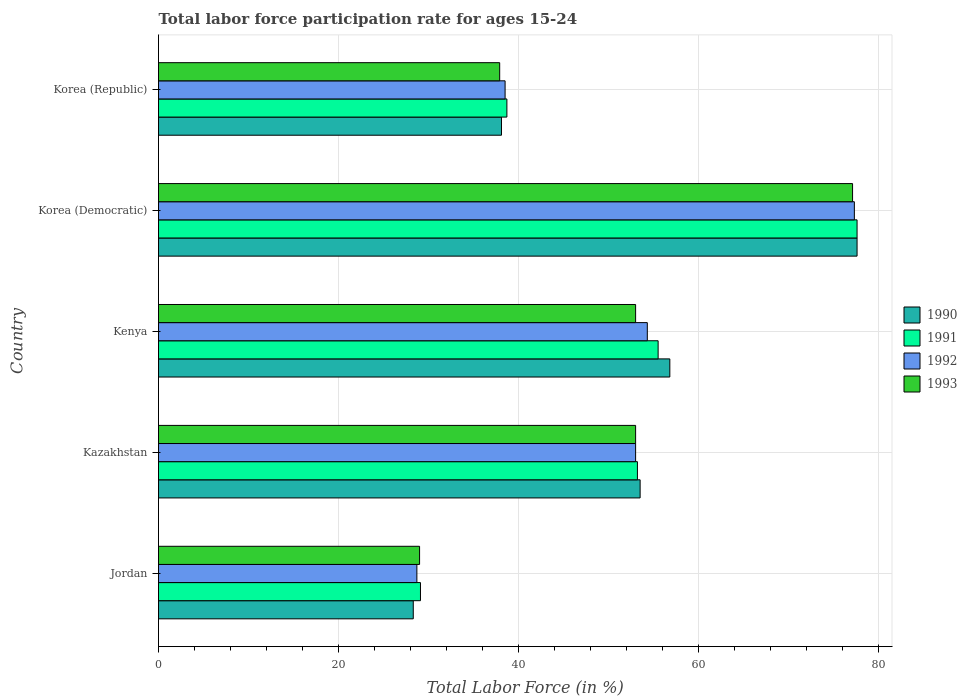How many different coloured bars are there?
Provide a short and direct response. 4. How many groups of bars are there?
Offer a very short reply. 5. Are the number of bars per tick equal to the number of legend labels?
Give a very brief answer. Yes. Are the number of bars on each tick of the Y-axis equal?
Offer a terse response. Yes. How many bars are there on the 2nd tick from the top?
Offer a very short reply. 4. How many bars are there on the 3rd tick from the bottom?
Your response must be concise. 4. What is the label of the 1st group of bars from the top?
Provide a succinct answer. Korea (Republic). In how many cases, is the number of bars for a given country not equal to the number of legend labels?
Your response must be concise. 0. What is the labor force participation rate in 1991 in Korea (Democratic)?
Provide a short and direct response. 77.6. Across all countries, what is the maximum labor force participation rate in 1993?
Provide a short and direct response. 77.1. Across all countries, what is the minimum labor force participation rate in 1990?
Ensure brevity in your answer.  28.3. In which country was the labor force participation rate in 1991 maximum?
Ensure brevity in your answer.  Korea (Democratic). In which country was the labor force participation rate in 1993 minimum?
Offer a terse response. Jordan. What is the total labor force participation rate in 1991 in the graph?
Provide a succinct answer. 254.1. What is the difference between the labor force participation rate in 1990 in Kenya and that in Korea (Democratic)?
Your answer should be very brief. -20.8. What is the difference between the labor force participation rate in 1993 in Jordan and the labor force participation rate in 1991 in Korea (Republic)?
Ensure brevity in your answer.  -9.7. What is the average labor force participation rate in 1993 per country?
Make the answer very short. 50. What is the difference between the labor force participation rate in 1991 and labor force participation rate in 1990 in Korea (Democratic)?
Offer a terse response. 0. In how many countries, is the labor force participation rate in 1991 greater than 76 %?
Offer a terse response. 1. What is the ratio of the labor force participation rate in 1992 in Kazakhstan to that in Kenya?
Make the answer very short. 0.98. Is the difference between the labor force participation rate in 1991 in Korea (Democratic) and Korea (Republic) greater than the difference between the labor force participation rate in 1990 in Korea (Democratic) and Korea (Republic)?
Your answer should be compact. No. What is the difference between the highest and the second highest labor force participation rate in 1990?
Keep it short and to the point. 20.8. What is the difference between the highest and the lowest labor force participation rate in 1993?
Provide a short and direct response. 48.1. Is the sum of the labor force participation rate in 1991 in Jordan and Kenya greater than the maximum labor force participation rate in 1992 across all countries?
Keep it short and to the point. Yes. How many bars are there?
Provide a succinct answer. 20. What is the difference between two consecutive major ticks on the X-axis?
Offer a terse response. 20. Does the graph contain any zero values?
Make the answer very short. No. Does the graph contain grids?
Offer a terse response. Yes. Where does the legend appear in the graph?
Your answer should be very brief. Center right. How many legend labels are there?
Offer a very short reply. 4. How are the legend labels stacked?
Give a very brief answer. Vertical. What is the title of the graph?
Your answer should be very brief. Total labor force participation rate for ages 15-24. Does "1979" appear as one of the legend labels in the graph?
Give a very brief answer. No. What is the label or title of the Y-axis?
Your answer should be compact. Country. What is the Total Labor Force (in %) in 1990 in Jordan?
Provide a succinct answer. 28.3. What is the Total Labor Force (in %) of 1991 in Jordan?
Provide a short and direct response. 29.1. What is the Total Labor Force (in %) of 1992 in Jordan?
Offer a very short reply. 28.7. What is the Total Labor Force (in %) in 1990 in Kazakhstan?
Offer a very short reply. 53.5. What is the Total Labor Force (in %) in 1991 in Kazakhstan?
Your response must be concise. 53.2. What is the Total Labor Force (in %) in 1993 in Kazakhstan?
Offer a terse response. 53. What is the Total Labor Force (in %) in 1990 in Kenya?
Ensure brevity in your answer.  56.8. What is the Total Labor Force (in %) in 1991 in Kenya?
Give a very brief answer. 55.5. What is the Total Labor Force (in %) in 1992 in Kenya?
Provide a short and direct response. 54.3. What is the Total Labor Force (in %) in 1993 in Kenya?
Make the answer very short. 53. What is the Total Labor Force (in %) in 1990 in Korea (Democratic)?
Give a very brief answer. 77.6. What is the Total Labor Force (in %) of 1991 in Korea (Democratic)?
Give a very brief answer. 77.6. What is the Total Labor Force (in %) of 1992 in Korea (Democratic)?
Ensure brevity in your answer.  77.3. What is the Total Labor Force (in %) in 1993 in Korea (Democratic)?
Your response must be concise. 77.1. What is the Total Labor Force (in %) of 1990 in Korea (Republic)?
Provide a short and direct response. 38.1. What is the Total Labor Force (in %) of 1991 in Korea (Republic)?
Keep it short and to the point. 38.7. What is the Total Labor Force (in %) of 1992 in Korea (Republic)?
Ensure brevity in your answer.  38.5. What is the Total Labor Force (in %) of 1993 in Korea (Republic)?
Your answer should be very brief. 37.9. Across all countries, what is the maximum Total Labor Force (in %) of 1990?
Provide a short and direct response. 77.6. Across all countries, what is the maximum Total Labor Force (in %) of 1991?
Your response must be concise. 77.6. Across all countries, what is the maximum Total Labor Force (in %) in 1992?
Your response must be concise. 77.3. Across all countries, what is the maximum Total Labor Force (in %) of 1993?
Keep it short and to the point. 77.1. Across all countries, what is the minimum Total Labor Force (in %) of 1990?
Offer a terse response. 28.3. Across all countries, what is the minimum Total Labor Force (in %) in 1991?
Ensure brevity in your answer.  29.1. Across all countries, what is the minimum Total Labor Force (in %) in 1992?
Provide a short and direct response. 28.7. Across all countries, what is the minimum Total Labor Force (in %) of 1993?
Ensure brevity in your answer.  29. What is the total Total Labor Force (in %) of 1990 in the graph?
Your answer should be very brief. 254.3. What is the total Total Labor Force (in %) of 1991 in the graph?
Your answer should be very brief. 254.1. What is the total Total Labor Force (in %) in 1992 in the graph?
Provide a succinct answer. 251.8. What is the total Total Labor Force (in %) in 1993 in the graph?
Offer a very short reply. 250. What is the difference between the Total Labor Force (in %) of 1990 in Jordan and that in Kazakhstan?
Your answer should be very brief. -25.2. What is the difference between the Total Labor Force (in %) in 1991 in Jordan and that in Kazakhstan?
Make the answer very short. -24.1. What is the difference between the Total Labor Force (in %) in 1992 in Jordan and that in Kazakhstan?
Your response must be concise. -24.3. What is the difference between the Total Labor Force (in %) of 1993 in Jordan and that in Kazakhstan?
Your answer should be very brief. -24. What is the difference between the Total Labor Force (in %) in 1990 in Jordan and that in Kenya?
Your answer should be very brief. -28.5. What is the difference between the Total Labor Force (in %) of 1991 in Jordan and that in Kenya?
Ensure brevity in your answer.  -26.4. What is the difference between the Total Labor Force (in %) of 1992 in Jordan and that in Kenya?
Offer a terse response. -25.6. What is the difference between the Total Labor Force (in %) in 1993 in Jordan and that in Kenya?
Ensure brevity in your answer.  -24. What is the difference between the Total Labor Force (in %) of 1990 in Jordan and that in Korea (Democratic)?
Your response must be concise. -49.3. What is the difference between the Total Labor Force (in %) of 1991 in Jordan and that in Korea (Democratic)?
Your answer should be very brief. -48.5. What is the difference between the Total Labor Force (in %) of 1992 in Jordan and that in Korea (Democratic)?
Your response must be concise. -48.6. What is the difference between the Total Labor Force (in %) of 1993 in Jordan and that in Korea (Democratic)?
Offer a very short reply. -48.1. What is the difference between the Total Labor Force (in %) of 1990 in Jordan and that in Korea (Republic)?
Give a very brief answer. -9.8. What is the difference between the Total Labor Force (in %) in 1991 in Jordan and that in Korea (Republic)?
Offer a very short reply. -9.6. What is the difference between the Total Labor Force (in %) of 1992 in Jordan and that in Korea (Republic)?
Provide a succinct answer. -9.8. What is the difference between the Total Labor Force (in %) of 1991 in Kazakhstan and that in Kenya?
Give a very brief answer. -2.3. What is the difference between the Total Labor Force (in %) of 1990 in Kazakhstan and that in Korea (Democratic)?
Make the answer very short. -24.1. What is the difference between the Total Labor Force (in %) in 1991 in Kazakhstan and that in Korea (Democratic)?
Provide a short and direct response. -24.4. What is the difference between the Total Labor Force (in %) of 1992 in Kazakhstan and that in Korea (Democratic)?
Provide a succinct answer. -24.3. What is the difference between the Total Labor Force (in %) of 1993 in Kazakhstan and that in Korea (Democratic)?
Your response must be concise. -24.1. What is the difference between the Total Labor Force (in %) of 1990 in Kenya and that in Korea (Democratic)?
Give a very brief answer. -20.8. What is the difference between the Total Labor Force (in %) of 1991 in Kenya and that in Korea (Democratic)?
Keep it short and to the point. -22.1. What is the difference between the Total Labor Force (in %) of 1992 in Kenya and that in Korea (Democratic)?
Give a very brief answer. -23. What is the difference between the Total Labor Force (in %) of 1993 in Kenya and that in Korea (Democratic)?
Your answer should be compact. -24.1. What is the difference between the Total Labor Force (in %) of 1991 in Kenya and that in Korea (Republic)?
Your answer should be compact. 16.8. What is the difference between the Total Labor Force (in %) of 1993 in Kenya and that in Korea (Republic)?
Keep it short and to the point. 15.1. What is the difference between the Total Labor Force (in %) in 1990 in Korea (Democratic) and that in Korea (Republic)?
Your response must be concise. 39.5. What is the difference between the Total Labor Force (in %) in 1991 in Korea (Democratic) and that in Korea (Republic)?
Provide a succinct answer. 38.9. What is the difference between the Total Labor Force (in %) of 1992 in Korea (Democratic) and that in Korea (Republic)?
Keep it short and to the point. 38.8. What is the difference between the Total Labor Force (in %) of 1993 in Korea (Democratic) and that in Korea (Republic)?
Provide a succinct answer. 39.2. What is the difference between the Total Labor Force (in %) of 1990 in Jordan and the Total Labor Force (in %) of 1991 in Kazakhstan?
Keep it short and to the point. -24.9. What is the difference between the Total Labor Force (in %) in 1990 in Jordan and the Total Labor Force (in %) in 1992 in Kazakhstan?
Offer a terse response. -24.7. What is the difference between the Total Labor Force (in %) of 1990 in Jordan and the Total Labor Force (in %) of 1993 in Kazakhstan?
Give a very brief answer. -24.7. What is the difference between the Total Labor Force (in %) in 1991 in Jordan and the Total Labor Force (in %) in 1992 in Kazakhstan?
Keep it short and to the point. -23.9. What is the difference between the Total Labor Force (in %) of 1991 in Jordan and the Total Labor Force (in %) of 1993 in Kazakhstan?
Make the answer very short. -23.9. What is the difference between the Total Labor Force (in %) in 1992 in Jordan and the Total Labor Force (in %) in 1993 in Kazakhstan?
Offer a terse response. -24.3. What is the difference between the Total Labor Force (in %) in 1990 in Jordan and the Total Labor Force (in %) in 1991 in Kenya?
Give a very brief answer. -27.2. What is the difference between the Total Labor Force (in %) in 1990 in Jordan and the Total Labor Force (in %) in 1992 in Kenya?
Keep it short and to the point. -26. What is the difference between the Total Labor Force (in %) of 1990 in Jordan and the Total Labor Force (in %) of 1993 in Kenya?
Your answer should be compact. -24.7. What is the difference between the Total Labor Force (in %) of 1991 in Jordan and the Total Labor Force (in %) of 1992 in Kenya?
Your response must be concise. -25.2. What is the difference between the Total Labor Force (in %) of 1991 in Jordan and the Total Labor Force (in %) of 1993 in Kenya?
Offer a terse response. -23.9. What is the difference between the Total Labor Force (in %) of 1992 in Jordan and the Total Labor Force (in %) of 1993 in Kenya?
Your answer should be compact. -24.3. What is the difference between the Total Labor Force (in %) in 1990 in Jordan and the Total Labor Force (in %) in 1991 in Korea (Democratic)?
Provide a succinct answer. -49.3. What is the difference between the Total Labor Force (in %) in 1990 in Jordan and the Total Labor Force (in %) in 1992 in Korea (Democratic)?
Provide a short and direct response. -49. What is the difference between the Total Labor Force (in %) of 1990 in Jordan and the Total Labor Force (in %) of 1993 in Korea (Democratic)?
Your answer should be very brief. -48.8. What is the difference between the Total Labor Force (in %) in 1991 in Jordan and the Total Labor Force (in %) in 1992 in Korea (Democratic)?
Give a very brief answer. -48.2. What is the difference between the Total Labor Force (in %) of 1991 in Jordan and the Total Labor Force (in %) of 1993 in Korea (Democratic)?
Offer a terse response. -48. What is the difference between the Total Labor Force (in %) in 1992 in Jordan and the Total Labor Force (in %) in 1993 in Korea (Democratic)?
Your answer should be very brief. -48.4. What is the difference between the Total Labor Force (in %) in 1990 in Jordan and the Total Labor Force (in %) in 1992 in Korea (Republic)?
Your answer should be very brief. -10.2. What is the difference between the Total Labor Force (in %) of 1991 in Jordan and the Total Labor Force (in %) of 1992 in Korea (Republic)?
Your answer should be very brief. -9.4. What is the difference between the Total Labor Force (in %) in 1991 in Jordan and the Total Labor Force (in %) in 1993 in Korea (Republic)?
Offer a terse response. -8.8. What is the difference between the Total Labor Force (in %) of 1992 in Jordan and the Total Labor Force (in %) of 1993 in Korea (Republic)?
Your answer should be very brief. -9.2. What is the difference between the Total Labor Force (in %) of 1990 in Kazakhstan and the Total Labor Force (in %) of 1991 in Kenya?
Offer a terse response. -2. What is the difference between the Total Labor Force (in %) in 1990 in Kazakhstan and the Total Labor Force (in %) in 1993 in Kenya?
Ensure brevity in your answer.  0.5. What is the difference between the Total Labor Force (in %) of 1992 in Kazakhstan and the Total Labor Force (in %) of 1993 in Kenya?
Offer a terse response. 0. What is the difference between the Total Labor Force (in %) in 1990 in Kazakhstan and the Total Labor Force (in %) in 1991 in Korea (Democratic)?
Your answer should be very brief. -24.1. What is the difference between the Total Labor Force (in %) of 1990 in Kazakhstan and the Total Labor Force (in %) of 1992 in Korea (Democratic)?
Your answer should be very brief. -23.8. What is the difference between the Total Labor Force (in %) of 1990 in Kazakhstan and the Total Labor Force (in %) of 1993 in Korea (Democratic)?
Your answer should be very brief. -23.6. What is the difference between the Total Labor Force (in %) of 1991 in Kazakhstan and the Total Labor Force (in %) of 1992 in Korea (Democratic)?
Provide a succinct answer. -24.1. What is the difference between the Total Labor Force (in %) in 1991 in Kazakhstan and the Total Labor Force (in %) in 1993 in Korea (Democratic)?
Offer a terse response. -23.9. What is the difference between the Total Labor Force (in %) in 1992 in Kazakhstan and the Total Labor Force (in %) in 1993 in Korea (Democratic)?
Your answer should be compact. -24.1. What is the difference between the Total Labor Force (in %) of 1990 in Kazakhstan and the Total Labor Force (in %) of 1992 in Korea (Republic)?
Your response must be concise. 15. What is the difference between the Total Labor Force (in %) of 1990 in Kazakhstan and the Total Labor Force (in %) of 1993 in Korea (Republic)?
Ensure brevity in your answer.  15.6. What is the difference between the Total Labor Force (in %) in 1991 in Kazakhstan and the Total Labor Force (in %) in 1992 in Korea (Republic)?
Ensure brevity in your answer.  14.7. What is the difference between the Total Labor Force (in %) in 1991 in Kazakhstan and the Total Labor Force (in %) in 1993 in Korea (Republic)?
Your answer should be compact. 15.3. What is the difference between the Total Labor Force (in %) of 1992 in Kazakhstan and the Total Labor Force (in %) of 1993 in Korea (Republic)?
Your answer should be compact. 15.1. What is the difference between the Total Labor Force (in %) in 1990 in Kenya and the Total Labor Force (in %) in 1991 in Korea (Democratic)?
Your answer should be compact. -20.8. What is the difference between the Total Labor Force (in %) in 1990 in Kenya and the Total Labor Force (in %) in 1992 in Korea (Democratic)?
Give a very brief answer. -20.5. What is the difference between the Total Labor Force (in %) in 1990 in Kenya and the Total Labor Force (in %) in 1993 in Korea (Democratic)?
Your answer should be compact. -20.3. What is the difference between the Total Labor Force (in %) in 1991 in Kenya and the Total Labor Force (in %) in 1992 in Korea (Democratic)?
Provide a succinct answer. -21.8. What is the difference between the Total Labor Force (in %) in 1991 in Kenya and the Total Labor Force (in %) in 1993 in Korea (Democratic)?
Keep it short and to the point. -21.6. What is the difference between the Total Labor Force (in %) in 1992 in Kenya and the Total Labor Force (in %) in 1993 in Korea (Democratic)?
Provide a short and direct response. -22.8. What is the difference between the Total Labor Force (in %) of 1990 in Kenya and the Total Labor Force (in %) of 1992 in Korea (Republic)?
Make the answer very short. 18.3. What is the difference between the Total Labor Force (in %) of 1990 in Kenya and the Total Labor Force (in %) of 1993 in Korea (Republic)?
Your answer should be compact. 18.9. What is the difference between the Total Labor Force (in %) of 1991 in Kenya and the Total Labor Force (in %) of 1992 in Korea (Republic)?
Your response must be concise. 17. What is the difference between the Total Labor Force (in %) of 1991 in Kenya and the Total Labor Force (in %) of 1993 in Korea (Republic)?
Your answer should be very brief. 17.6. What is the difference between the Total Labor Force (in %) in 1992 in Kenya and the Total Labor Force (in %) in 1993 in Korea (Republic)?
Your response must be concise. 16.4. What is the difference between the Total Labor Force (in %) in 1990 in Korea (Democratic) and the Total Labor Force (in %) in 1991 in Korea (Republic)?
Provide a short and direct response. 38.9. What is the difference between the Total Labor Force (in %) of 1990 in Korea (Democratic) and the Total Labor Force (in %) of 1992 in Korea (Republic)?
Provide a short and direct response. 39.1. What is the difference between the Total Labor Force (in %) in 1990 in Korea (Democratic) and the Total Labor Force (in %) in 1993 in Korea (Republic)?
Give a very brief answer. 39.7. What is the difference between the Total Labor Force (in %) in 1991 in Korea (Democratic) and the Total Labor Force (in %) in 1992 in Korea (Republic)?
Make the answer very short. 39.1. What is the difference between the Total Labor Force (in %) in 1991 in Korea (Democratic) and the Total Labor Force (in %) in 1993 in Korea (Republic)?
Your answer should be very brief. 39.7. What is the difference between the Total Labor Force (in %) of 1992 in Korea (Democratic) and the Total Labor Force (in %) of 1993 in Korea (Republic)?
Offer a terse response. 39.4. What is the average Total Labor Force (in %) of 1990 per country?
Your answer should be very brief. 50.86. What is the average Total Labor Force (in %) in 1991 per country?
Give a very brief answer. 50.82. What is the average Total Labor Force (in %) of 1992 per country?
Your response must be concise. 50.36. What is the difference between the Total Labor Force (in %) in 1990 and Total Labor Force (in %) in 1991 in Jordan?
Offer a terse response. -0.8. What is the difference between the Total Labor Force (in %) of 1990 and Total Labor Force (in %) of 1992 in Jordan?
Provide a succinct answer. -0.4. What is the difference between the Total Labor Force (in %) of 1990 and Total Labor Force (in %) of 1993 in Jordan?
Ensure brevity in your answer.  -0.7. What is the difference between the Total Labor Force (in %) in 1991 and Total Labor Force (in %) in 1992 in Jordan?
Give a very brief answer. 0.4. What is the difference between the Total Labor Force (in %) of 1992 and Total Labor Force (in %) of 1993 in Jordan?
Make the answer very short. -0.3. What is the difference between the Total Labor Force (in %) of 1990 and Total Labor Force (in %) of 1993 in Kazakhstan?
Give a very brief answer. 0.5. What is the difference between the Total Labor Force (in %) in 1991 and Total Labor Force (in %) in 1992 in Kazakhstan?
Provide a short and direct response. 0.2. What is the difference between the Total Labor Force (in %) of 1991 and Total Labor Force (in %) of 1993 in Kazakhstan?
Provide a short and direct response. 0.2. What is the difference between the Total Labor Force (in %) of 1992 and Total Labor Force (in %) of 1993 in Kazakhstan?
Offer a terse response. 0. What is the difference between the Total Labor Force (in %) of 1990 and Total Labor Force (in %) of 1991 in Kenya?
Offer a terse response. 1.3. What is the difference between the Total Labor Force (in %) in 1990 and Total Labor Force (in %) in 1992 in Kenya?
Offer a very short reply. 2.5. What is the difference between the Total Labor Force (in %) of 1991 and Total Labor Force (in %) of 1993 in Kenya?
Your answer should be very brief. 2.5. What is the difference between the Total Labor Force (in %) of 1990 and Total Labor Force (in %) of 1993 in Korea (Democratic)?
Your answer should be very brief. 0.5. What is the difference between the Total Labor Force (in %) of 1991 and Total Labor Force (in %) of 1992 in Korea (Democratic)?
Ensure brevity in your answer.  0.3. What is the difference between the Total Labor Force (in %) of 1991 and Total Labor Force (in %) of 1993 in Korea (Democratic)?
Keep it short and to the point. 0.5. What is the difference between the Total Labor Force (in %) in 1992 and Total Labor Force (in %) in 1993 in Korea (Democratic)?
Give a very brief answer. 0.2. What is the difference between the Total Labor Force (in %) in 1990 and Total Labor Force (in %) in 1992 in Korea (Republic)?
Provide a short and direct response. -0.4. What is the difference between the Total Labor Force (in %) in 1990 and Total Labor Force (in %) in 1993 in Korea (Republic)?
Give a very brief answer. 0.2. What is the difference between the Total Labor Force (in %) in 1991 and Total Labor Force (in %) in 1993 in Korea (Republic)?
Offer a terse response. 0.8. What is the ratio of the Total Labor Force (in %) of 1990 in Jordan to that in Kazakhstan?
Your answer should be very brief. 0.53. What is the ratio of the Total Labor Force (in %) of 1991 in Jordan to that in Kazakhstan?
Ensure brevity in your answer.  0.55. What is the ratio of the Total Labor Force (in %) of 1992 in Jordan to that in Kazakhstan?
Your answer should be very brief. 0.54. What is the ratio of the Total Labor Force (in %) of 1993 in Jordan to that in Kazakhstan?
Your answer should be compact. 0.55. What is the ratio of the Total Labor Force (in %) of 1990 in Jordan to that in Kenya?
Keep it short and to the point. 0.5. What is the ratio of the Total Labor Force (in %) in 1991 in Jordan to that in Kenya?
Keep it short and to the point. 0.52. What is the ratio of the Total Labor Force (in %) in 1992 in Jordan to that in Kenya?
Offer a terse response. 0.53. What is the ratio of the Total Labor Force (in %) of 1993 in Jordan to that in Kenya?
Provide a succinct answer. 0.55. What is the ratio of the Total Labor Force (in %) of 1990 in Jordan to that in Korea (Democratic)?
Your answer should be compact. 0.36. What is the ratio of the Total Labor Force (in %) of 1991 in Jordan to that in Korea (Democratic)?
Your answer should be compact. 0.38. What is the ratio of the Total Labor Force (in %) of 1992 in Jordan to that in Korea (Democratic)?
Ensure brevity in your answer.  0.37. What is the ratio of the Total Labor Force (in %) of 1993 in Jordan to that in Korea (Democratic)?
Make the answer very short. 0.38. What is the ratio of the Total Labor Force (in %) of 1990 in Jordan to that in Korea (Republic)?
Your response must be concise. 0.74. What is the ratio of the Total Labor Force (in %) in 1991 in Jordan to that in Korea (Republic)?
Offer a terse response. 0.75. What is the ratio of the Total Labor Force (in %) in 1992 in Jordan to that in Korea (Republic)?
Your response must be concise. 0.75. What is the ratio of the Total Labor Force (in %) of 1993 in Jordan to that in Korea (Republic)?
Offer a terse response. 0.77. What is the ratio of the Total Labor Force (in %) in 1990 in Kazakhstan to that in Kenya?
Make the answer very short. 0.94. What is the ratio of the Total Labor Force (in %) in 1991 in Kazakhstan to that in Kenya?
Your answer should be compact. 0.96. What is the ratio of the Total Labor Force (in %) of 1992 in Kazakhstan to that in Kenya?
Provide a succinct answer. 0.98. What is the ratio of the Total Labor Force (in %) of 1993 in Kazakhstan to that in Kenya?
Give a very brief answer. 1. What is the ratio of the Total Labor Force (in %) in 1990 in Kazakhstan to that in Korea (Democratic)?
Keep it short and to the point. 0.69. What is the ratio of the Total Labor Force (in %) in 1991 in Kazakhstan to that in Korea (Democratic)?
Your response must be concise. 0.69. What is the ratio of the Total Labor Force (in %) in 1992 in Kazakhstan to that in Korea (Democratic)?
Offer a terse response. 0.69. What is the ratio of the Total Labor Force (in %) in 1993 in Kazakhstan to that in Korea (Democratic)?
Your answer should be compact. 0.69. What is the ratio of the Total Labor Force (in %) of 1990 in Kazakhstan to that in Korea (Republic)?
Offer a terse response. 1.4. What is the ratio of the Total Labor Force (in %) in 1991 in Kazakhstan to that in Korea (Republic)?
Your answer should be very brief. 1.37. What is the ratio of the Total Labor Force (in %) in 1992 in Kazakhstan to that in Korea (Republic)?
Your answer should be very brief. 1.38. What is the ratio of the Total Labor Force (in %) in 1993 in Kazakhstan to that in Korea (Republic)?
Provide a succinct answer. 1.4. What is the ratio of the Total Labor Force (in %) in 1990 in Kenya to that in Korea (Democratic)?
Provide a short and direct response. 0.73. What is the ratio of the Total Labor Force (in %) of 1991 in Kenya to that in Korea (Democratic)?
Make the answer very short. 0.72. What is the ratio of the Total Labor Force (in %) of 1992 in Kenya to that in Korea (Democratic)?
Provide a short and direct response. 0.7. What is the ratio of the Total Labor Force (in %) of 1993 in Kenya to that in Korea (Democratic)?
Give a very brief answer. 0.69. What is the ratio of the Total Labor Force (in %) in 1990 in Kenya to that in Korea (Republic)?
Offer a terse response. 1.49. What is the ratio of the Total Labor Force (in %) in 1991 in Kenya to that in Korea (Republic)?
Provide a short and direct response. 1.43. What is the ratio of the Total Labor Force (in %) in 1992 in Kenya to that in Korea (Republic)?
Give a very brief answer. 1.41. What is the ratio of the Total Labor Force (in %) of 1993 in Kenya to that in Korea (Republic)?
Provide a succinct answer. 1.4. What is the ratio of the Total Labor Force (in %) of 1990 in Korea (Democratic) to that in Korea (Republic)?
Give a very brief answer. 2.04. What is the ratio of the Total Labor Force (in %) in 1991 in Korea (Democratic) to that in Korea (Republic)?
Your response must be concise. 2.01. What is the ratio of the Total Labor Force (in %) in 1992 in Korea (Democratic) to that in Korea (Republic)?
Your answer should be compact. 2.01. What is the ratio of the Total Labor Force (in %) of 1993 in Korea (Democratic) to that in Korea (Republic)?
Ensure brevity in your answer.  2.03. What is the difference between the highest and the second highest Total Labor Force (in %) in 1990?
Give a very brief answer. 20.8. What is the difference between the highest and the second highest Total Labor Force (in %) in 1991?
Your answer should be compact. 22.1. What is the difference between the highest and the second highest Total Labor Force (in %) of 1992?
Offer a terse response. 23. What is the difference between the highest and the second highest Total Labor Force (in %) in 1993?
Your answer should be very brief. 24.1. What is the difference between the highest and the lowest Total Labor Force (in %) in 1990?
Provide a succinct answer. 49.3. What is the difference between the highest and the lowest Total Labor Force (in %) in 1991?
Ensure brevity in your answer.  48.5. What is the difference between the highest and the lowest Total Labor Force (in %) of 1992?
Offer a terse response. 48.6. What is the difference between the highest and the lowest Total Labor Force (in %) in 1993?
Give a very brief answer. 48.1. 